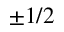Convert formula to latex. <formula><loc_0><loc_0><loc_500><loc_500>\pm 1 / 2</formula> 